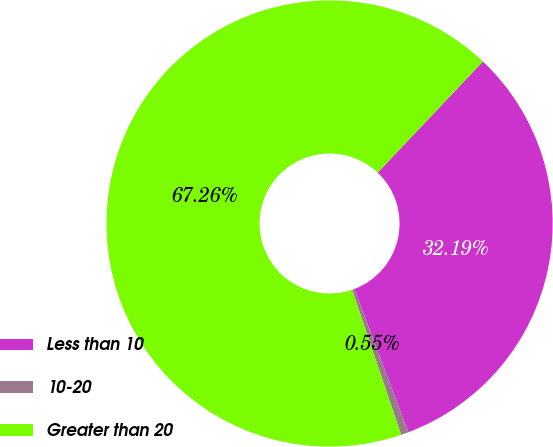Convert chart to OTSL. <chart><loc_0><loc_0><loc_500><loc_500><pie_chart><fcel>Less than 10<fcel>10-20<fcel>Greater than 20<nl><fcel>32.19%<fcel>0.55%<fcel>67.26%<nl></chart> 